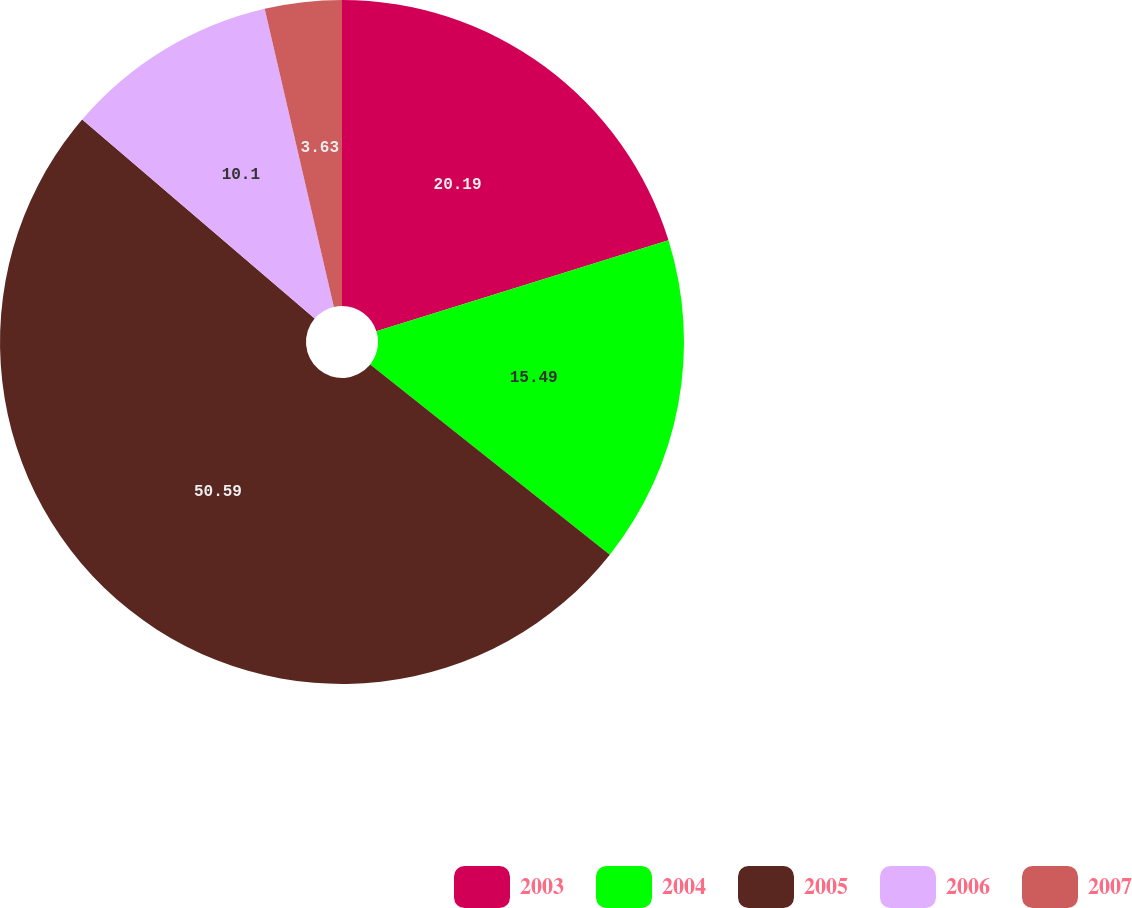<chart> <loc_0><loc_0><loc_500><loc_500><pie_chart><fcel>2003<fcel>2004<fcel>2005<fcel>2006<fcel>2007<nl><fcel>20.19%<fcel>15.49%<fcel>50.59%<fcel>10.1%<fcel>3.63%<nl></chart> 